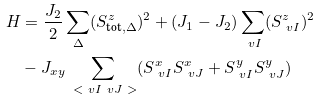Convert formula to latex. <formula><loc_0><loc_0><loc_500><loc_500>H & = \frac { J _ { 2 } } { 2 } \sum _ { \Delta } ( S ^ { z } _ { \text {tot} , \Delta } ) ^ { 2 } + ( J _ { 1 } - J _ { 2 } ) \sum _ { \ v I } ( S ^ { z } _ { \ v I } ) ^ { 2 } \\ & - J _ { x y } \sum _ { \ < \ v I \ v J \ > } ( S ^ { x } _ { \ v I } S ^ { x } _ { \ v J } + S ^ { y } _ { \ v I } S ^ { y } _ { \ v J } )</formula> 